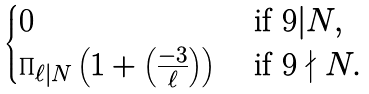<formula> <loc_0><loc_0><loc_500><loc_500>\begin{cases} 0 & \text { if } 9 | N , \\ \prod _ { \ell | N } \left ( 1 + \left ( \frac { - 3 } { \ell } \right ) \right ) & \text { if } 9 \nmid N . \end{cases}</formula> 